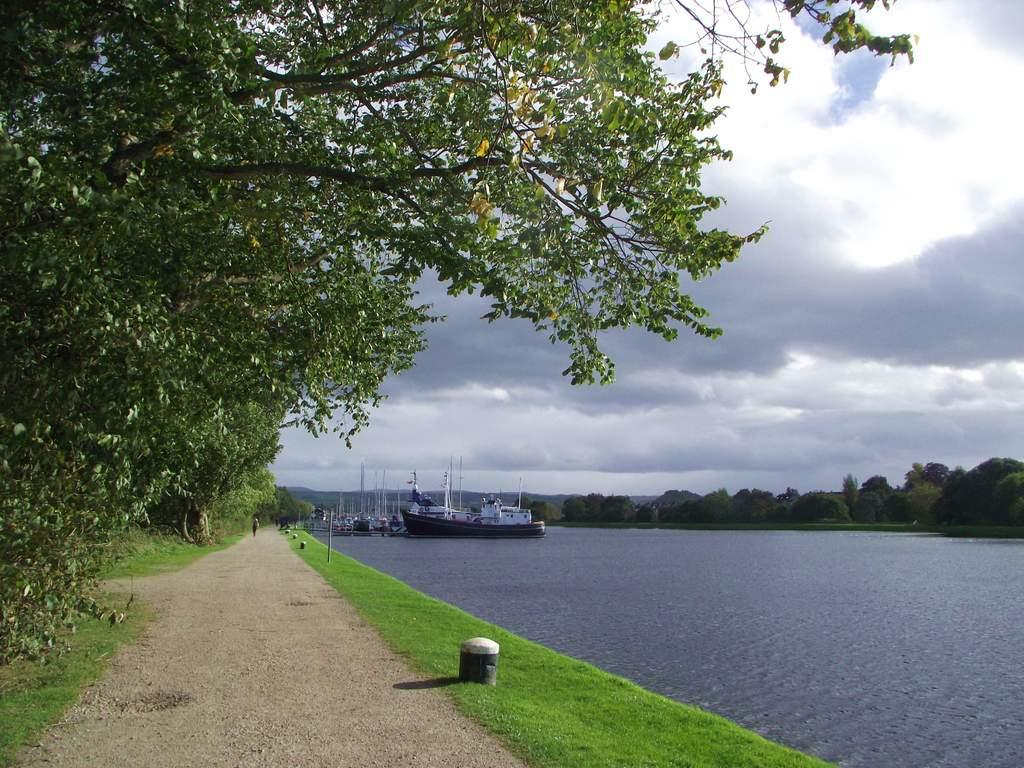What type of surface can be seen in the image? There is a pathway in the image. What type of vegetation is present in the image? There is grass and trees in the image. What body of water is visible in the image? There is a river with water in the image. What is floating on the water in the image? There are boats on the water. What is visible in the sky in the image? There are clouds in the sky. What page does the river turn to in the image? There are no pages in the image, as it is a photograph and not a book. What smell can be detected from the grass in the image? The image is a visual representation and does not convey smells, so it is not possible to determine the smell of the grass from the image. 